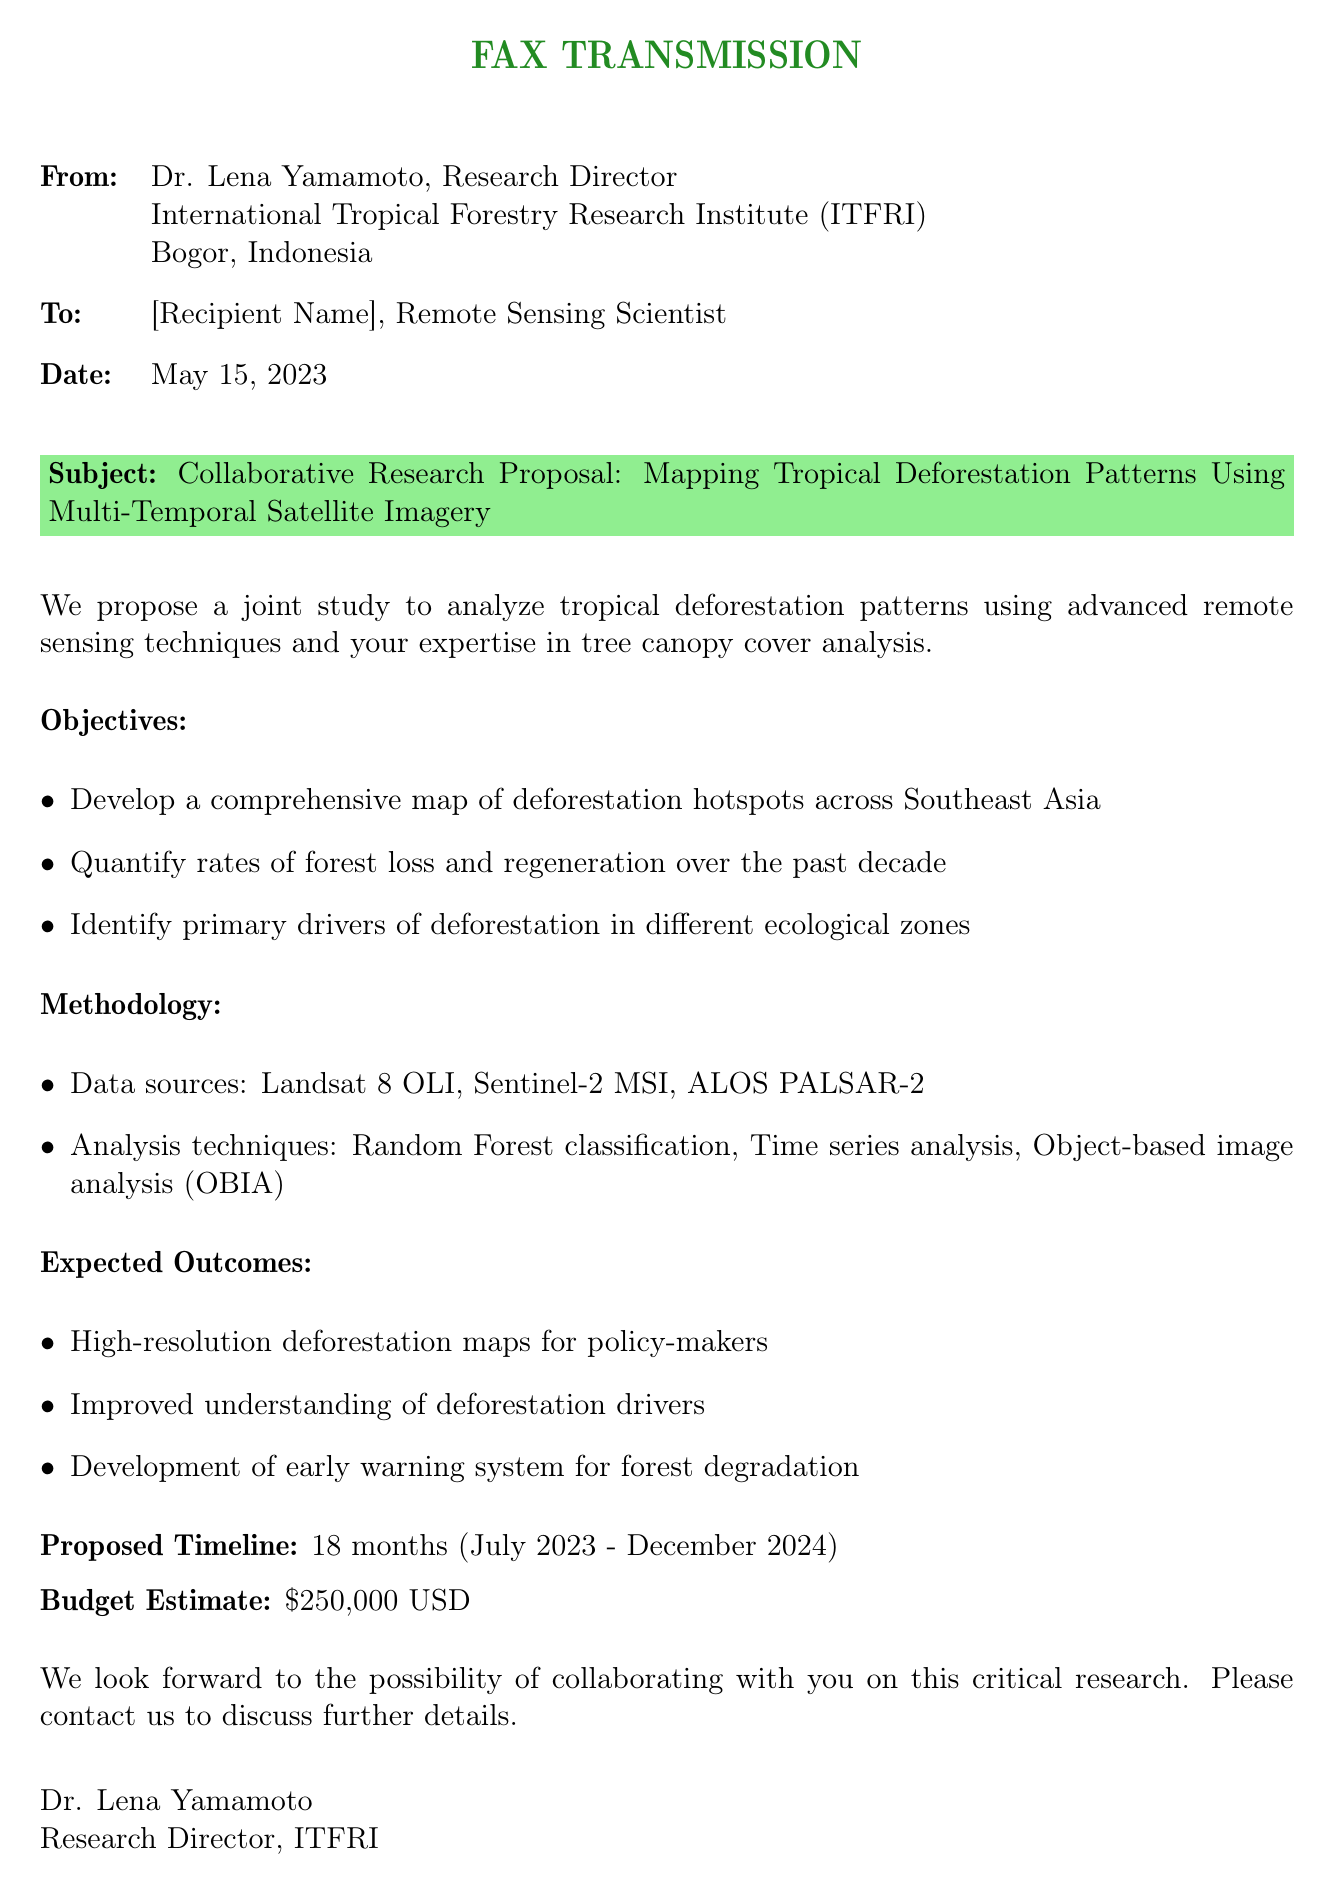What is the name of the sender? The sender of the fax is Dr. Lena Yamamoto, Research Director of the International Tropical Forestry Research Institute.
Answer: Dr. Lena Yamamoto What is the date of the fax? The fax was sent on May 15, 2023.
Answer: May 15, 2023 What is the proposed budget for the research? The budget estimate mentioned in the fax is $250,000 USD.
Answer: $250,000 USD What is the timeframe for the research project? The proposed timeline for the research is from July 2023 to December 2024, which is 18 months.
Answer: 18 months What is one of the data sources mentioned? One of the data sources listed in the methodology is Landsat 8 OLI.
Answer: Landsat 8 OLI What is the primary objective of the study? The primary objective includes developing a comprehensive map of deforestation hotspots across Southeast Asia.
Answer: Mapping deforestation hotspots What analysis technique is used in the study? The methodology mentions using Random Forest classification as one of the analysis techniques.
Answer: Random Forest classification What do the expected outcomes include? One expected outcome is high-resolution deforestation maps for policy-makers.
Answer: High-resolution deforestation maps What type of document is this? This is a fax transmission regarding a collaborative research proposal.
Answer: Fax transmission 